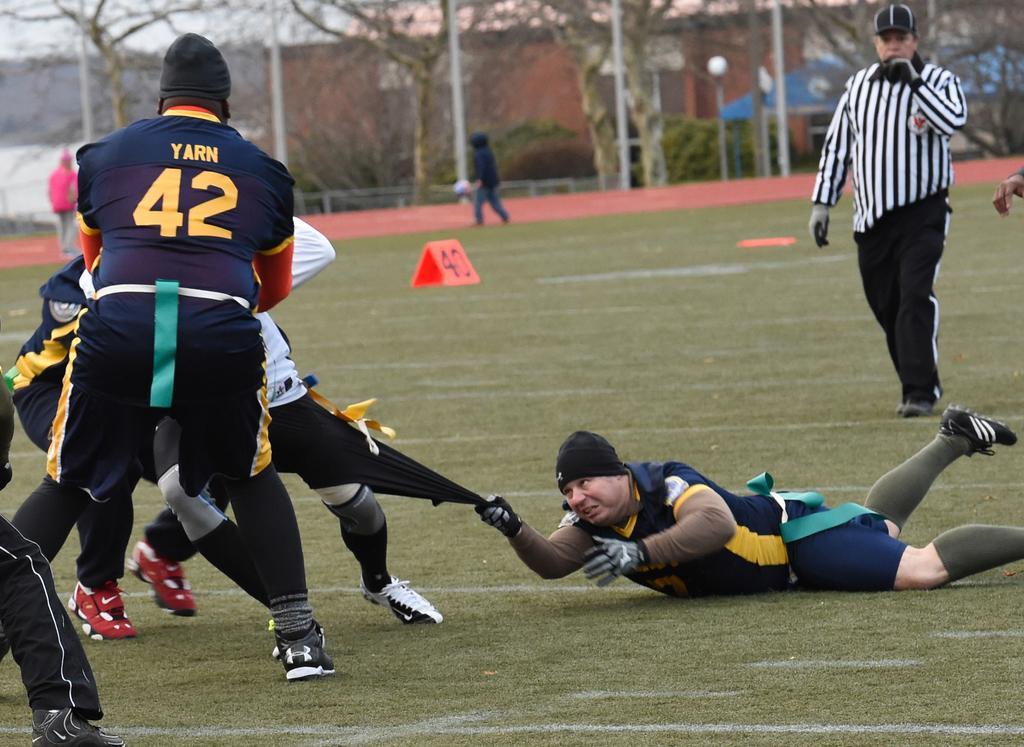Describe this image in one or two sentences. In this picture we can see a group of people on the ground and in the background we can see poles, trees, building, shed, fence, sky and some objects. 